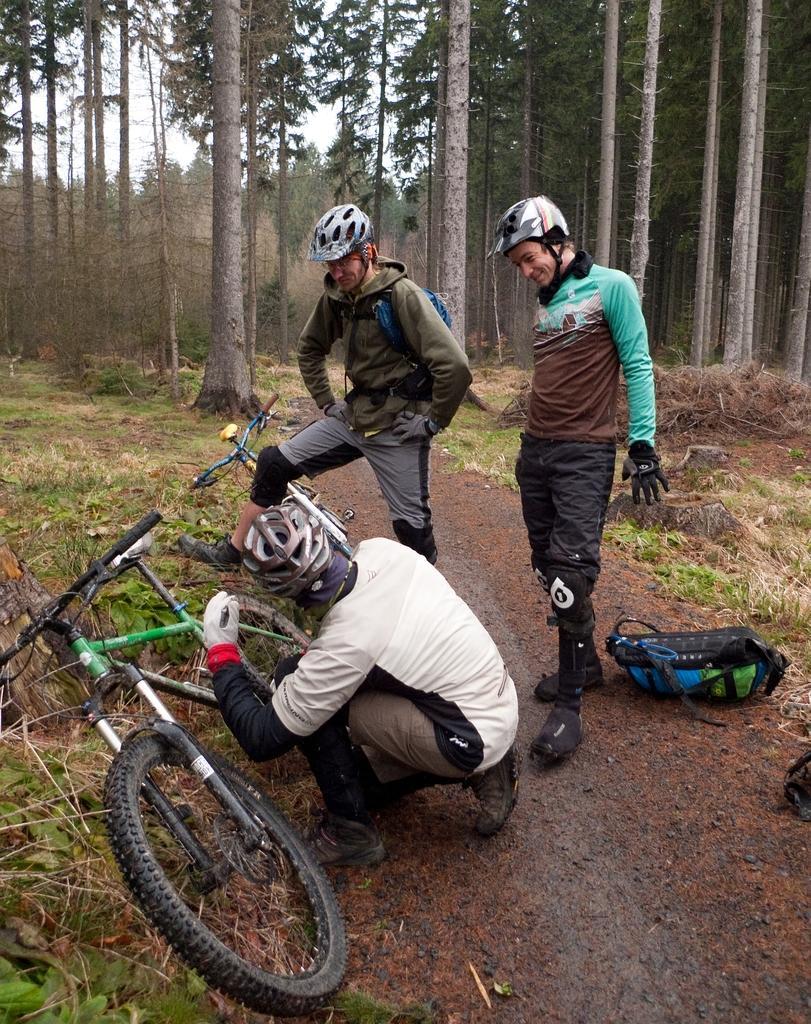Could you give a brief overview of what you see in this image? This picture describes about group of people, they wore helmets, in front of them we can see few bicycles, in the background we can find few trees and also we can see a bag on the right side of the image. 